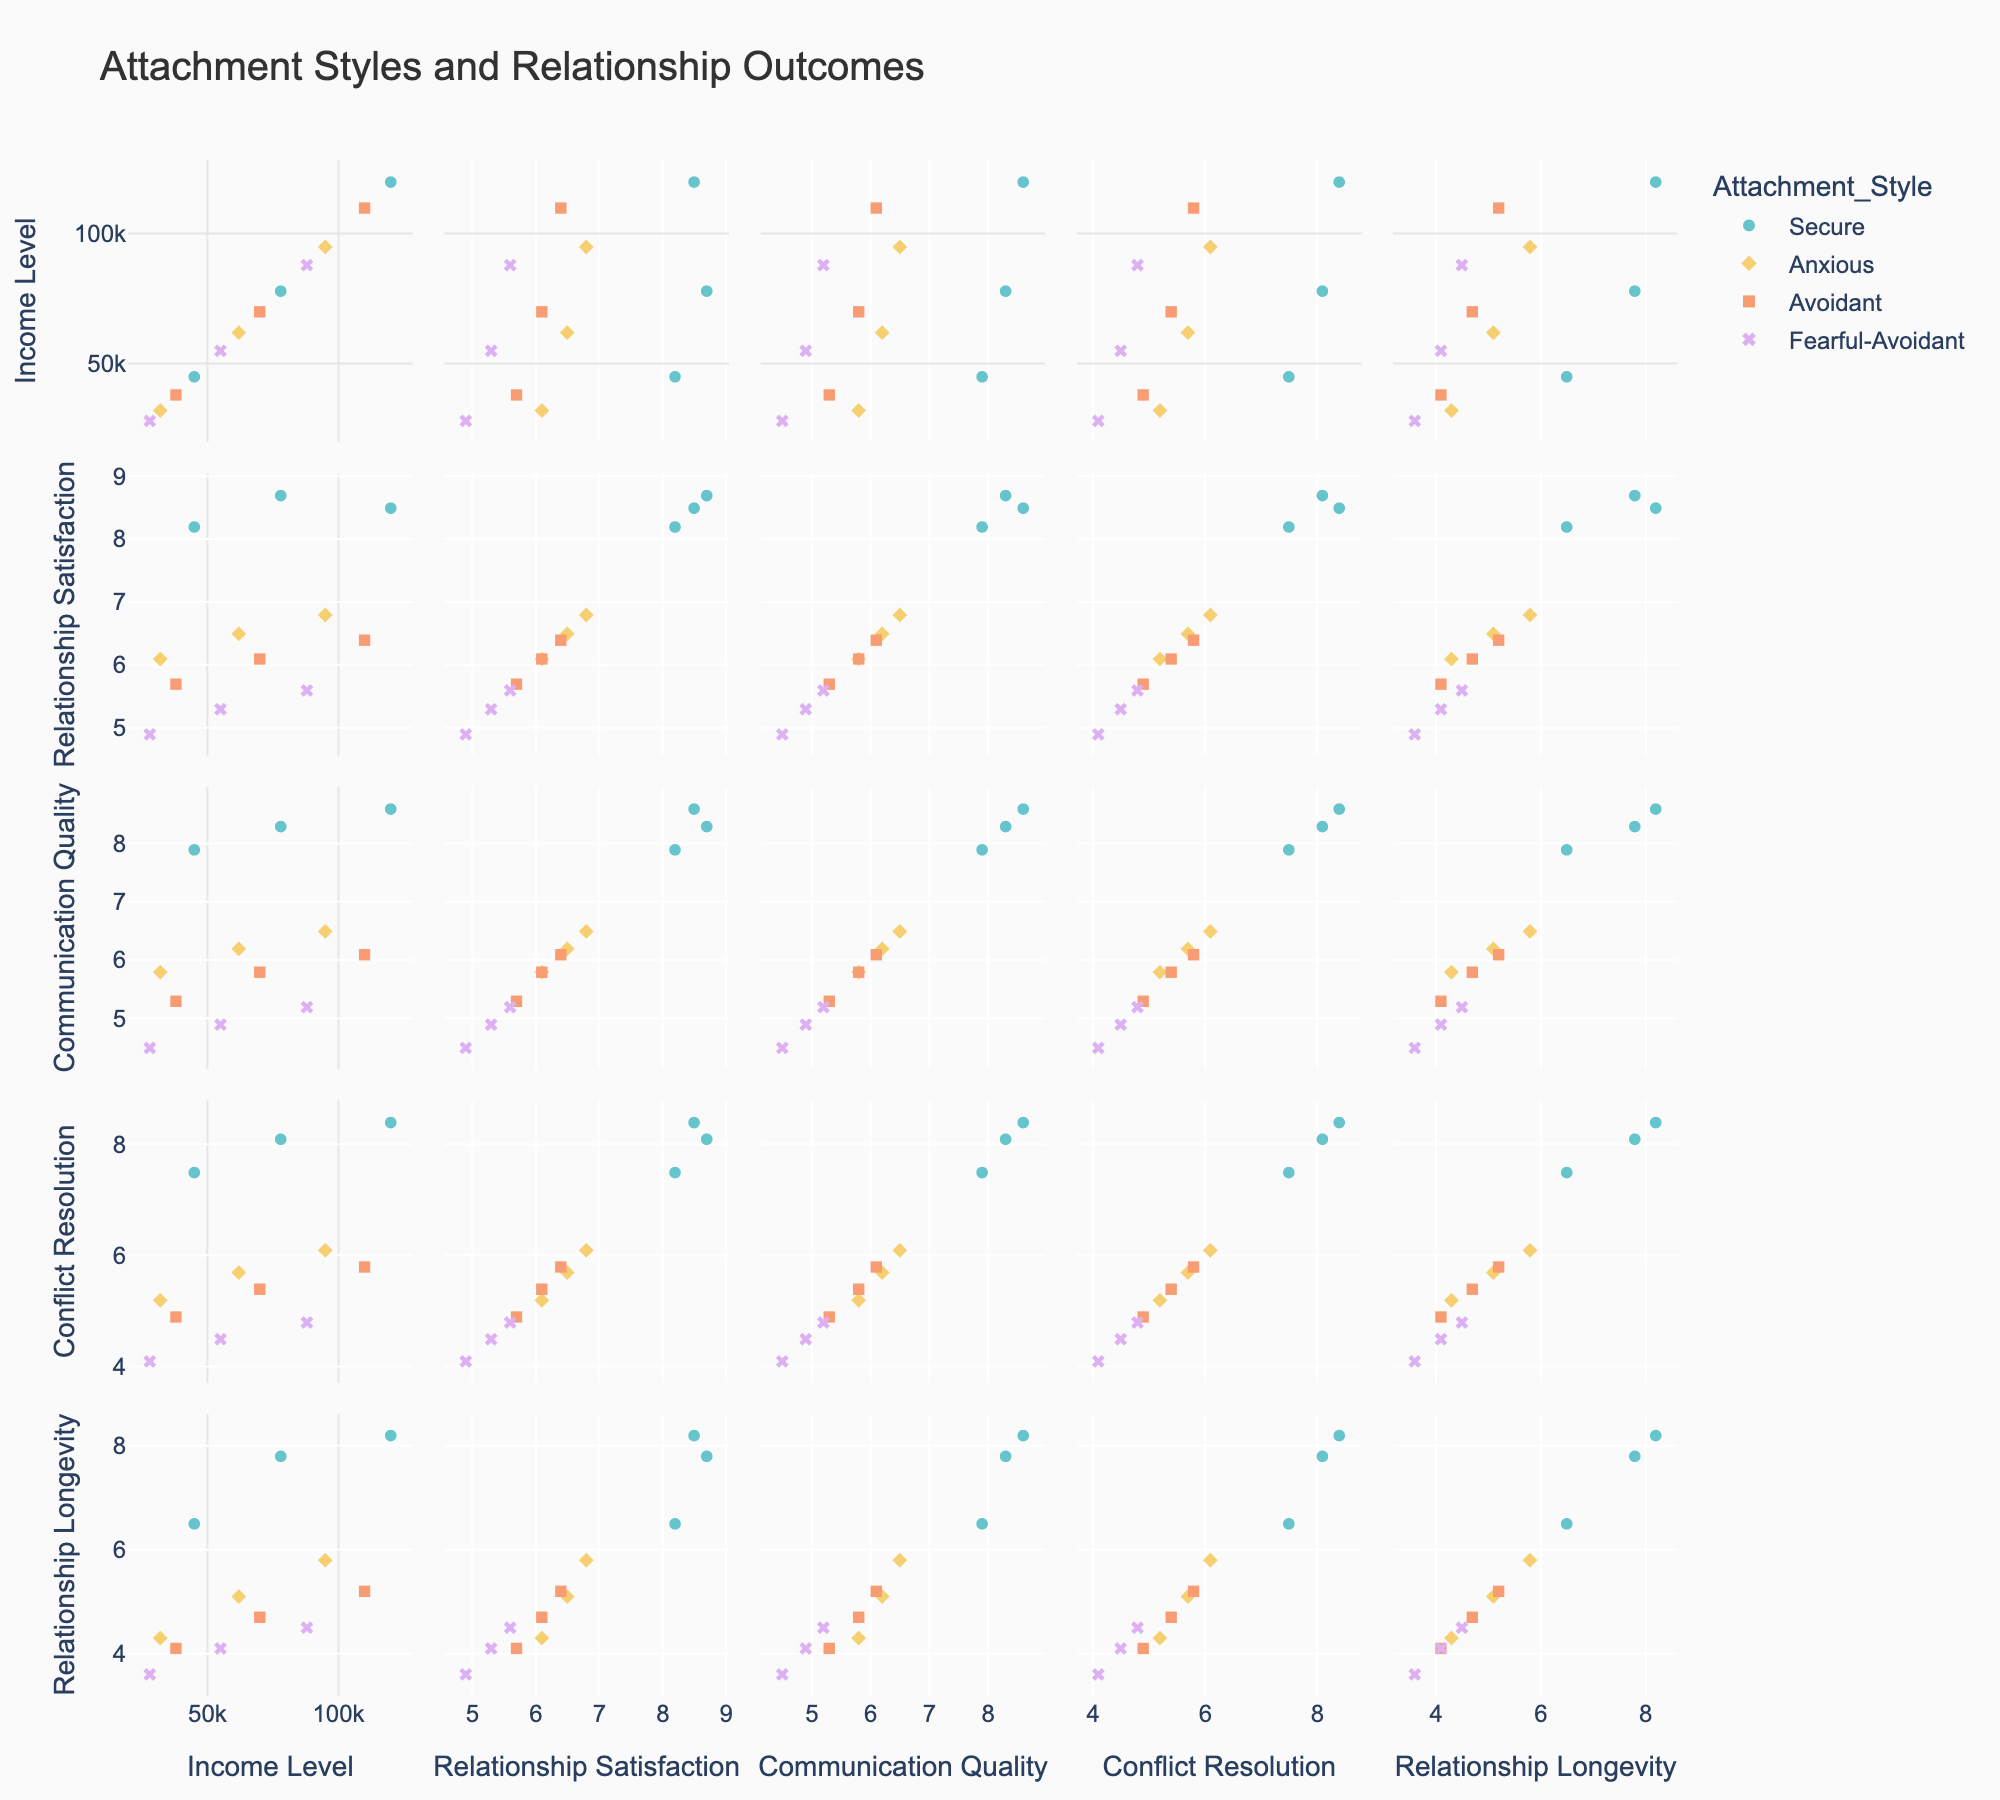What is the title of the figure? The title of the figure is located at the top center of the figure. By reading the title, you can identify the main topic of the figure.
Answer: Attachment Styles and Relationship Outcomes What is the range of Income Levels represented in the scatterplot matrix? Look at the x-axes labeled 'Income Level' in the scatterplot matrix. The minimum and maximum values represent the range of income levels.
Answer: $28,000 to $120,000 Which attachment style typically scores the highest in Relationship Satisfaction? Observe the scatter points in the Relationship Satisfaction column and identify which color, representing attachment style, is located higher up on the y-axis.
Answer: Secure Is there a noticeable trend between Income Level and Relationship Longevity? Look at the Income Level vs. Relationship Longevity cells in the matrix. Analyze if the points show an increasing or decreasing pattern.
Answer: Yes, there is a positive trend Which attachment style has the lowest average Communication Quality score? Identify the Communication Quality column and observe the spread of points for each attachment style. Compare the central tendency of each style's points.
Answer: Fearful-Avoidant Is there a difference in Conflict Resolution scores between Secure and Anxious attachment styles? Compare the range and central points of marker colors representing Secure and Anxious attachment styles in the Conflict Resolution column.
Answer: Yes, Secure has higher Conflict Resolution scores than Anxious Which two attachment styles show the closest Relationship Longevity scores at an income level of $70,000? Locate the points plotted at the $70,000 income level in the Relationship Longevity cell, and compare the y-values of different colors representing attachment styles.
Answer: Secure and Avoidant Does income level seem to affect Communication Quality for Avoidant attachment style? Look at the Income Level vs. Communication Quality cells, focusing on points with the Avoidant attachment style color. Check for any positive or negative trend.
Answer: Yes, higher income correlates with higher Communication Quality for Avoidant How does the Relationship Satisfaction of Secure attachment style at $78,000 compare to those of the other styles? Identify the point for Secure attachment style at $78,000 in the Relationship Satisfaction column and compare its y-value with the points of other attachment styles.
Answer: Higher than Anxious, Avoidant, and Fearful-Avoidant Which attachment style shows the greatest variation in Conflict Resolution scores? Observe the spread of points within the Conflict Resolution cells for each attachment style. The attachment style with the widest spread has the greatest variation.
Answer: Anxious 